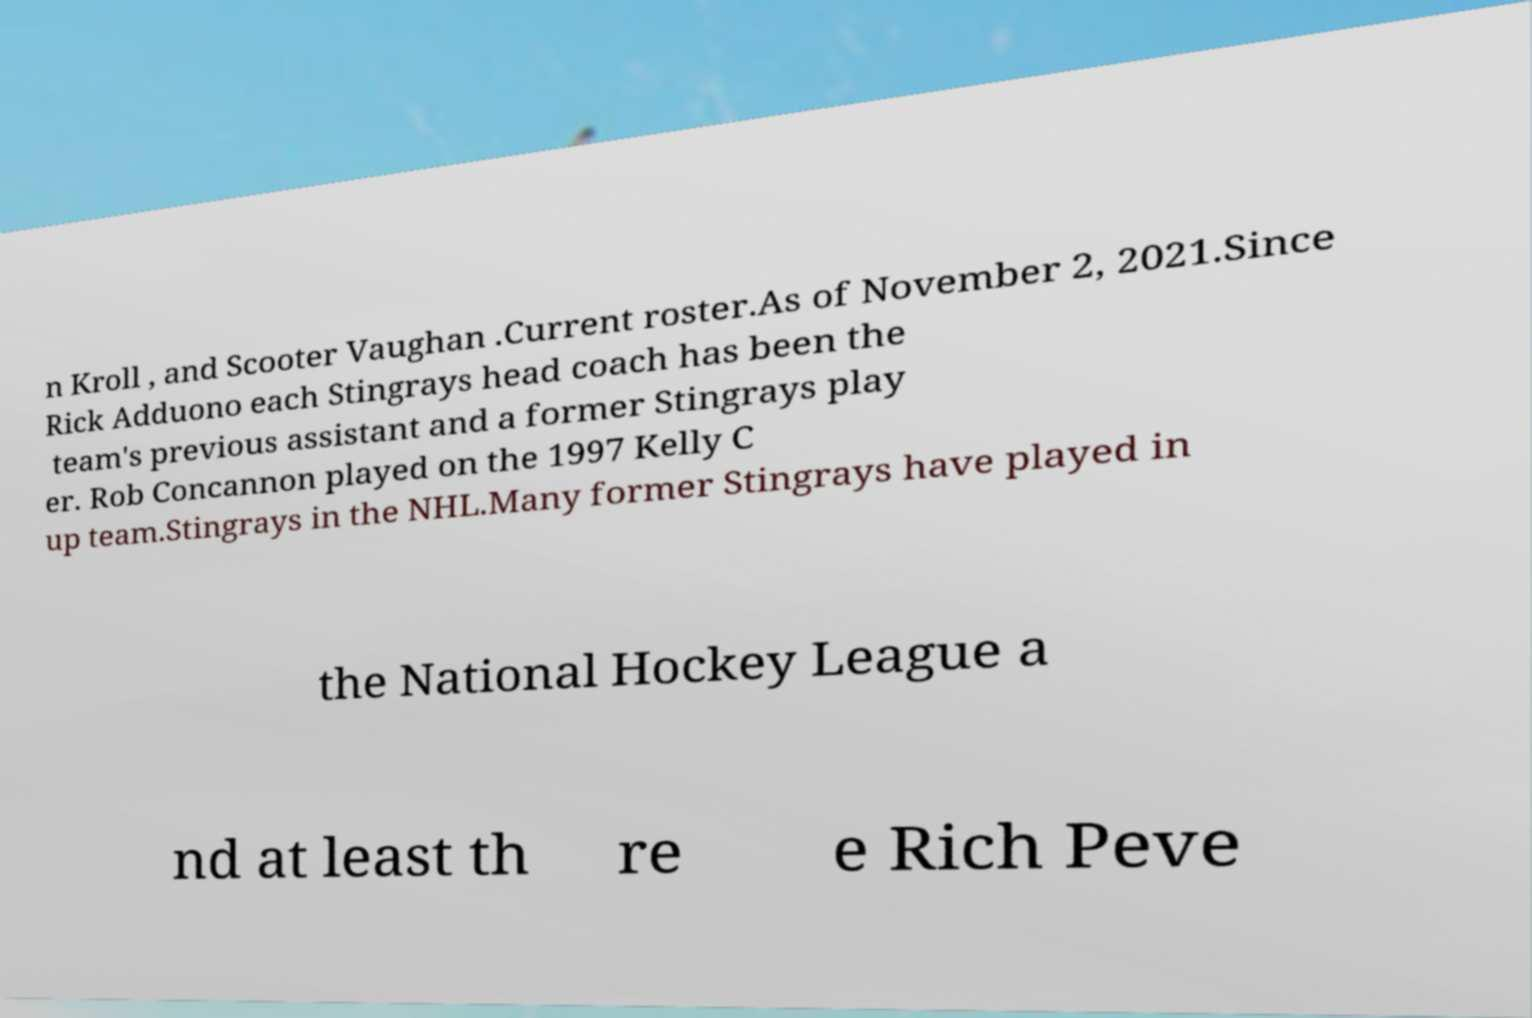Please read and relay the text visible in this image. What does it say? n Kroll , and Scooter Vaughan .Current roster.As of November 2, 2021.Since Rick Adduono each Stingrays head coach has been the team's previous assistant and a former Stingrays play er. Rob Concannon played on the 1997 Kelly C up team.Stingrays in the NHL.Many former Stingrays have played in the National Hockey League a nd at least th re e Rich Peve 